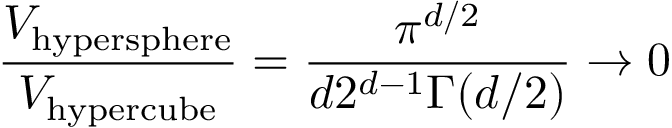Convert formula to latex. <formula><loc_0><loc_0><loc_500><loc_500>{ \frac { V _ { h y p e r s p h e r e } } { V _ { h y p e r c u b e } } } = { \frac { \pi ^ { d / 2 } } { d 2 ^ { d - 1 } \Gamma ( d / 2 ) } } \rightarrow 0</formula> 